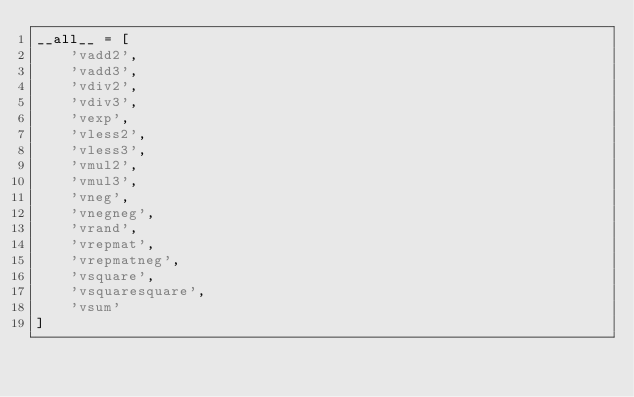<code> <loc_0><loc_0><loc_500><loc_500><_Python_>__all__ = [
    'vadd2',
    'vadd3',
    'vdiv2',
    'vdiv3',
    'vexp',
    'vless2',
    'vless3',
    'vmul2',
    'vmul3',
    'vneg',
    'vnegneg',
    'vrand',
    'vrepmat',
    'vrepmatneg',
    'vsquare',
    'vsquaresquare',
    'vsum'
]
</code> 